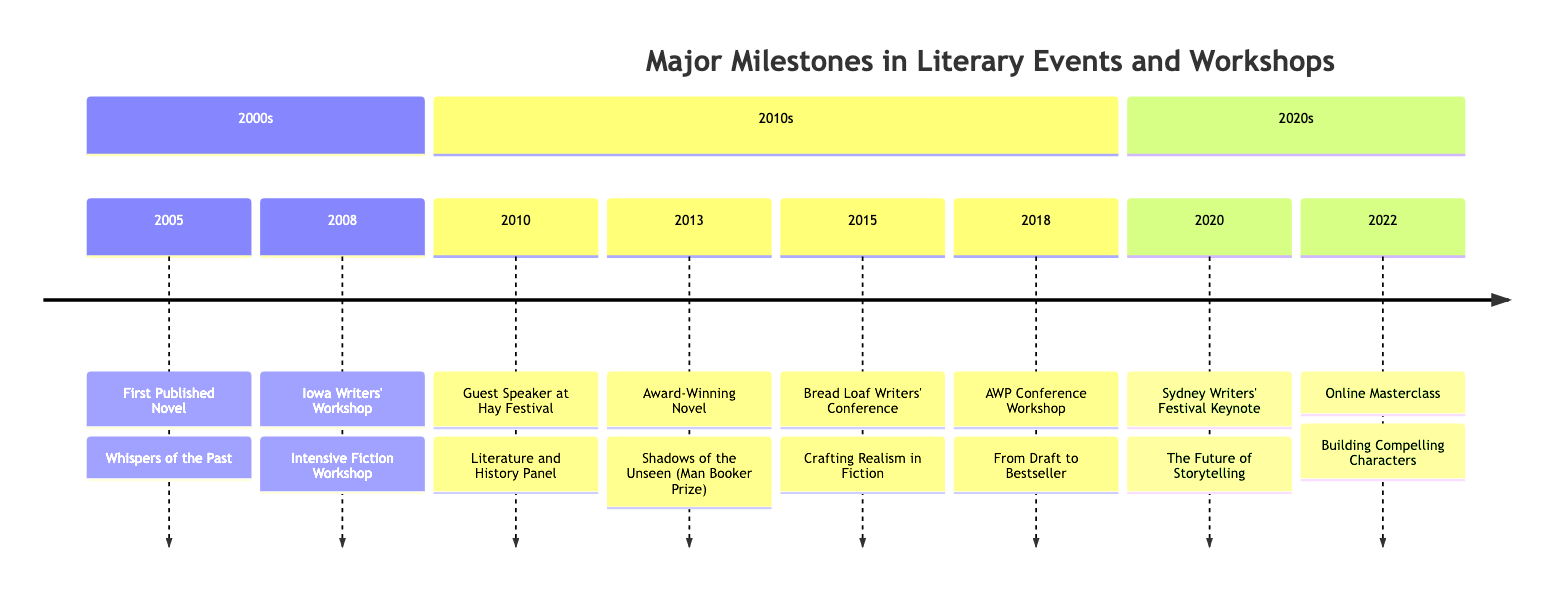What year was the first published novel? The first published novel is "Whispers of the Past," which occurred in 2005. Therefore, the year of the first published novel is 2005.
Answer: 2005 How many events are listed in the timeline? By counting each major milestone in the provided data, there are a total of 8 events listed in the timeline from 2005 to 2022.
Answer: 8 What award did the novel "Shadows of the Unseen" receive? "Shadows of the Unseen" is noted to have won the Man Booker Prize, making this its recognized award.
Answer: Man Booker Prize Where did the author lecture in 2015? The timeline states that the author lectured at the Bread Loaf Writers' Conference, which is located in Middlebury, VT, in 2015.
Answer: Middlebury, VT What title was featured at the Sydney Writers' Festival in 2020? The event at the Sydney Writers' Festival in 2020 featured the title "The Future of Storytelling." This information can be found directly associated with the specific event year.
Answer: The Future of Storytelling Which workshop did the author host in 2018? In 2018, the author hosted a workshop titled "From Draft to Bestseller" during the AWP Conference, as indicated in the timeline.
Answer: From Draft to Bestseller What type of event took place in 2022? The event conducted in 2022 was an "Online Masterclass" for Creative Writing, as stated in the details for that year.
Answer: Online Masterclass Which location is associated with the 2010 guest speaking event? The 2010 guest speaking event was held at the Hay Festival, located in Hay-on-Wye, Wales, according to the timeline details.
Answer: Hay-on-Wye, Wales 